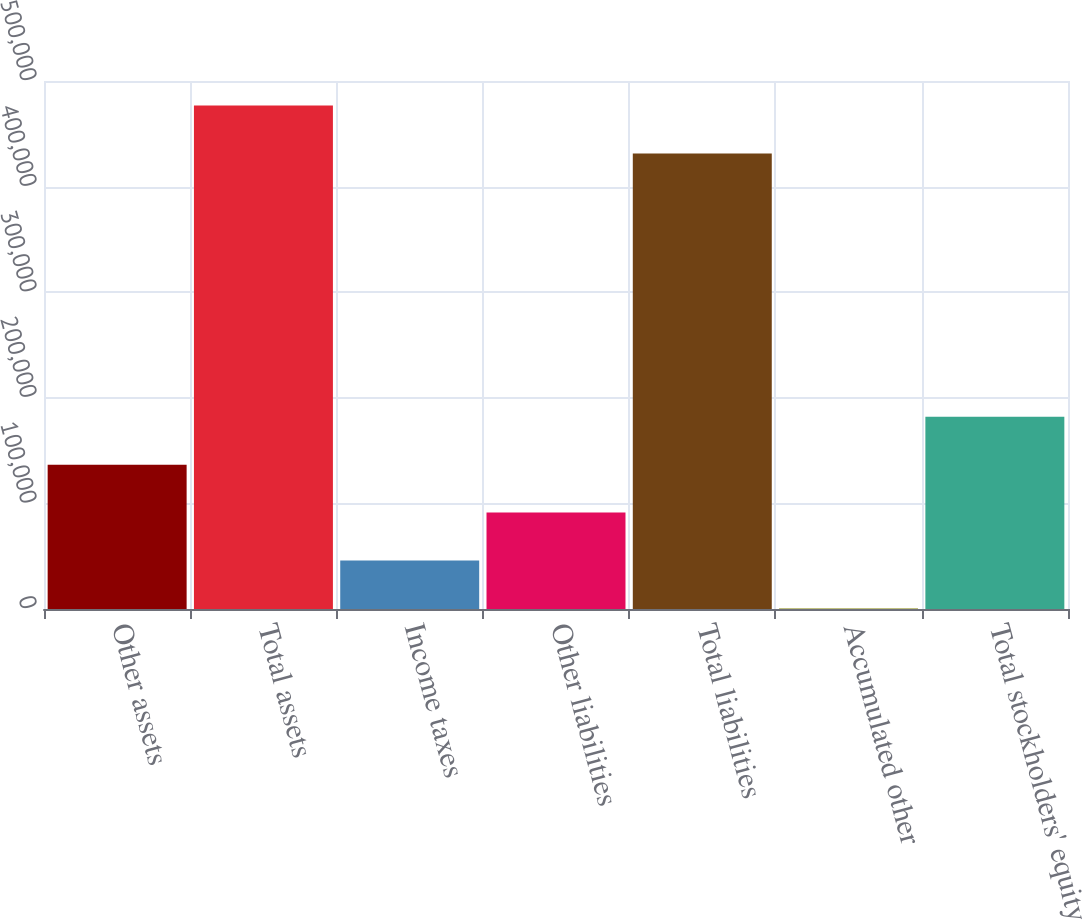<chart> <loc_0><loc_0><loc_500><loc_500><bar_chart><fcel>Other assets<fcel>Total assets<fcel>Income taxes<fcel>Other liabilities<fcel>Total liabilities<fcel>Accumulated other<fcel>Total stockholders' equity<nl><fcel>136643<fcel>476749<fcel>45893.7<fcel>91268.4<fcel>431374<fcel>519<fcel>182018<nl></chart> 